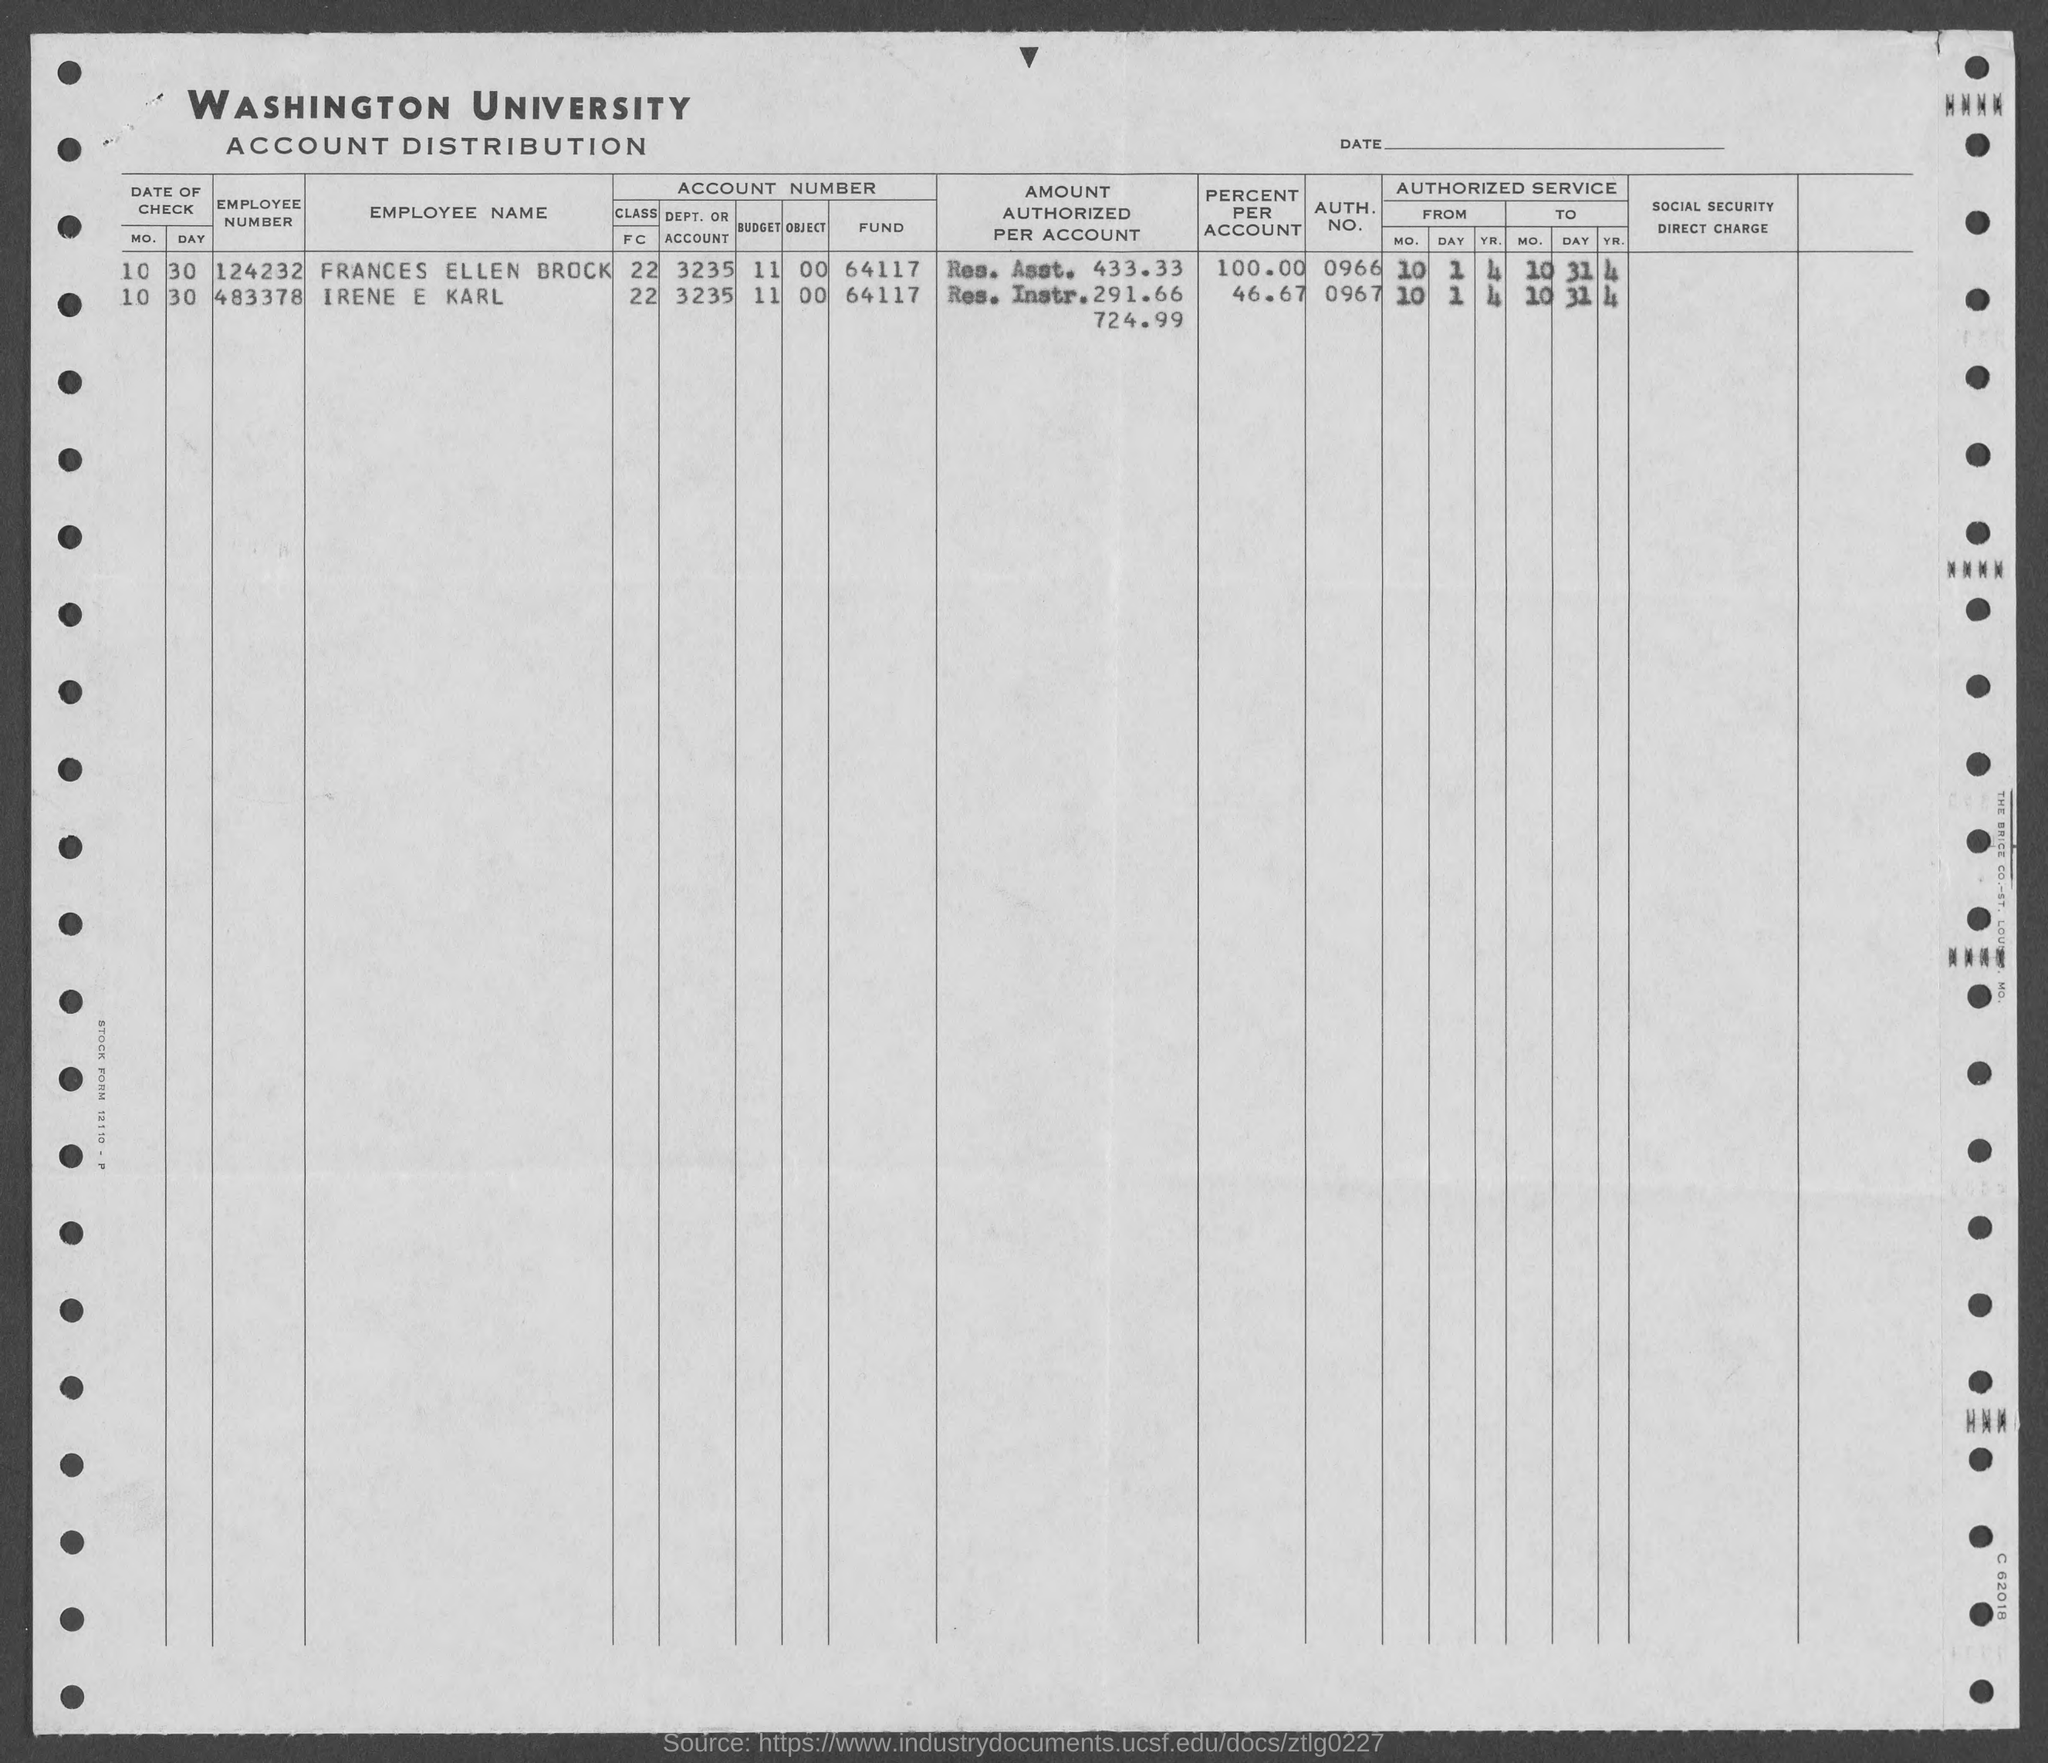What is the employee number given for frances ellen brock as mentioned in the given form ?
Provide a short and direct response. 124232. What is the employee number given for irene e karl ?
Ensure brevity in your answer.  483378. What is the date of check for frances ellen brock ?
Offer a terse response. 10 30. What is the auth. no. for frances ellen brock mentioned in the given page ?
Provide a succinct answer. 0966. What is the auth. no. for irene e karl ?
Give a very brief answer. 0967. What is the value of percent per account for frances ellen brock as mentioned in the given form ?
Give a very brief answer. 100.00. What is the value of percent per account for irene e karl as mentioned in the given form ?
Your answer should be compact. 46.67. 